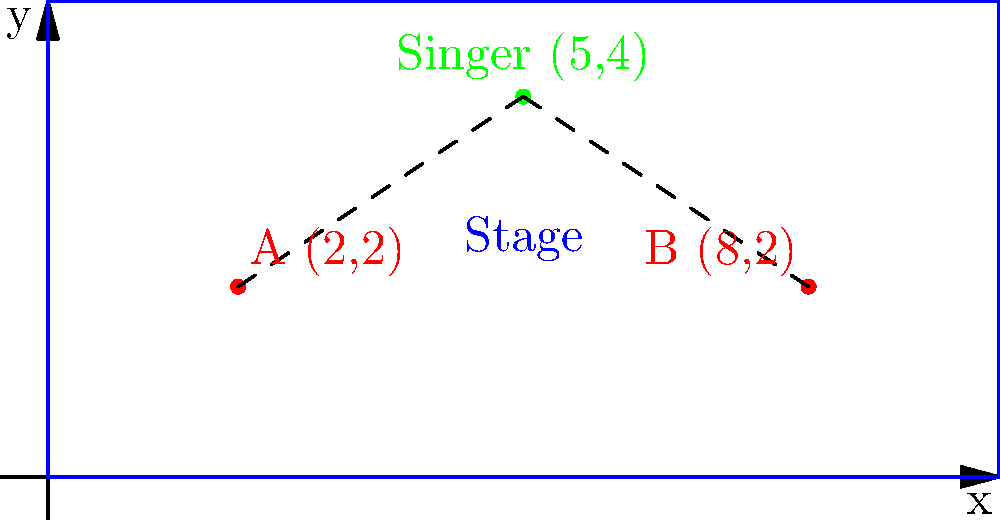As a singer, you want to optimize the speaker placement for your performance. On a coordinate plane representing the stage, you are positioned at (5,4). Two speakers are placed at A(2,2) and B(8,2). Using the distance formula, determine which speaker is closer to you and by how many units? Let's approach this step-by-step:

1) The distance formula between two points $(x_1, y_1)$ and $(x_2, y_2)$ is:
   $$d = \sqrt{(x_2 - x_1)^2 + (y_2 - y_1)^2}$$

2) Let's calculate the distance from the singer to speaker A:
   $d_A = \sqrt{(5-2)^2 + (4-2)^2}$
   $d_A = \sqrt{3^2 + 2^2}$
   $d_A = \sqrt{9 + 4}$
   $d_A = \sqrt{13}$

3) Now, let's calculate the distance from the singer to speaker B:
   $d_B = \sqrt{(5-8)^2 + (4-2)^2}$
   $d_B = \sqrt{(-3)^2 + 2^2}$
   $d_B = \sqrt{9 + 4}$
   $d_B = \sqrt{13}$

4) We can see that $d_A = d_B = \sqrt{13}$

5) Therefore, both speakers are equidistant from the singer.

6) The difference in distance is $\sqrt{13} - \sqrt{13} = 0$ units.
Answer: Both speakers are equidistant; 0 units difference. 